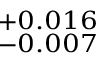Convert formula to latex. <formula><loc_0><loc_0><loc_500><loc_500>^ { + 0 . 0 1 6 } _ { - 0 . 0 0 7 }</formula> 